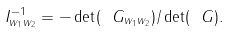<formula> <loc_0><loc_0><loc_500><loc_500>I ^ { - 1 } _ { w _ { 1 } w _ { 2 } } = - \det ( \ G _ { w _ { 1 } w _ { 2 } } ) / \det ( \ G ) .</formula> 